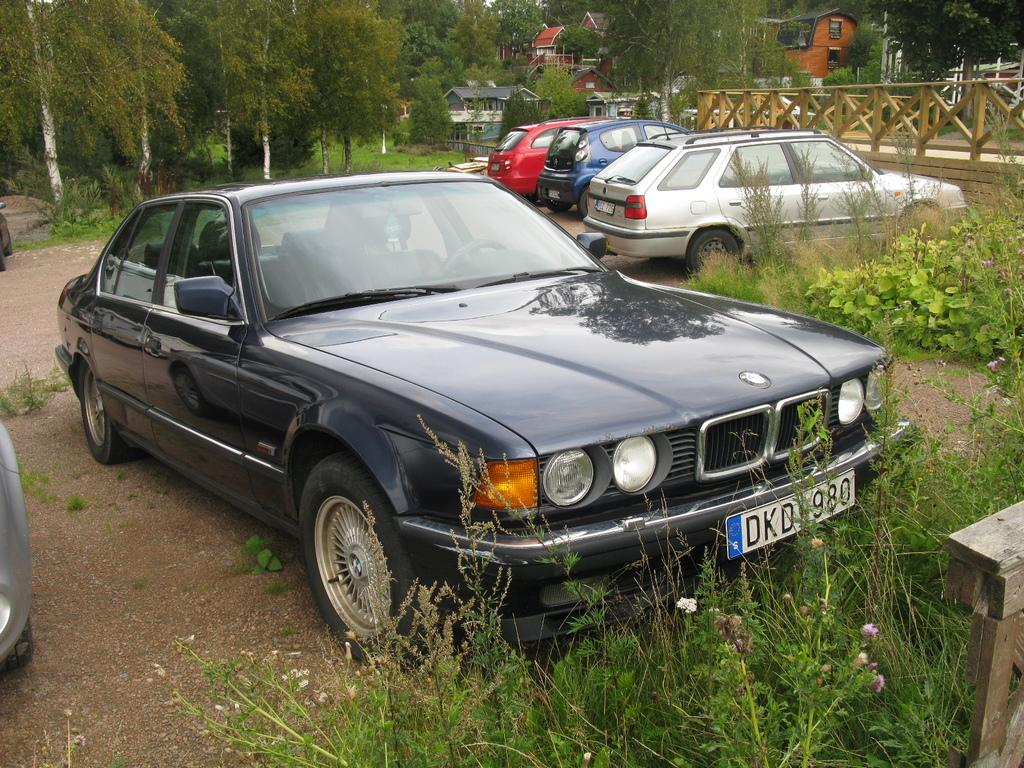What can be seen on the ground in the image? There are cars parked on the ground in the image. What type of vegetation is present on the right side of the image? There are plants and grasses on the right side of the image. What is visible at the back of the image? There are trees and houses visible at the back of the image. Reasoning: Let's think step by step by step in order to produce the conversation. We start by identifying the main subjects and objects in the image based on the provided facts. We then formulate questions that focus on the location and characteristics of these subjects and objects, ensuring that each question can be answered definitively with the information given. We avoid yes/no questions and ensure that the language is simple and clear. Absurd Question/Answer: What type of lamp is used to illuminate the temper of the record in the image? There is no lamp, temper, or record present in the image. What type of lamp is used to illuminate the temper of the record in the image? There is no lamp, temper, or record present in the image. 